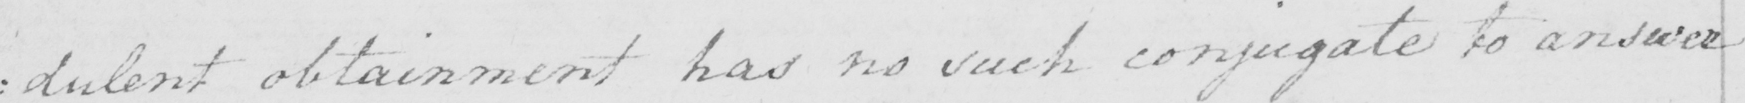Please provide the text content of this handwritten line. : dulent obtainment has no such conjugate to answer 